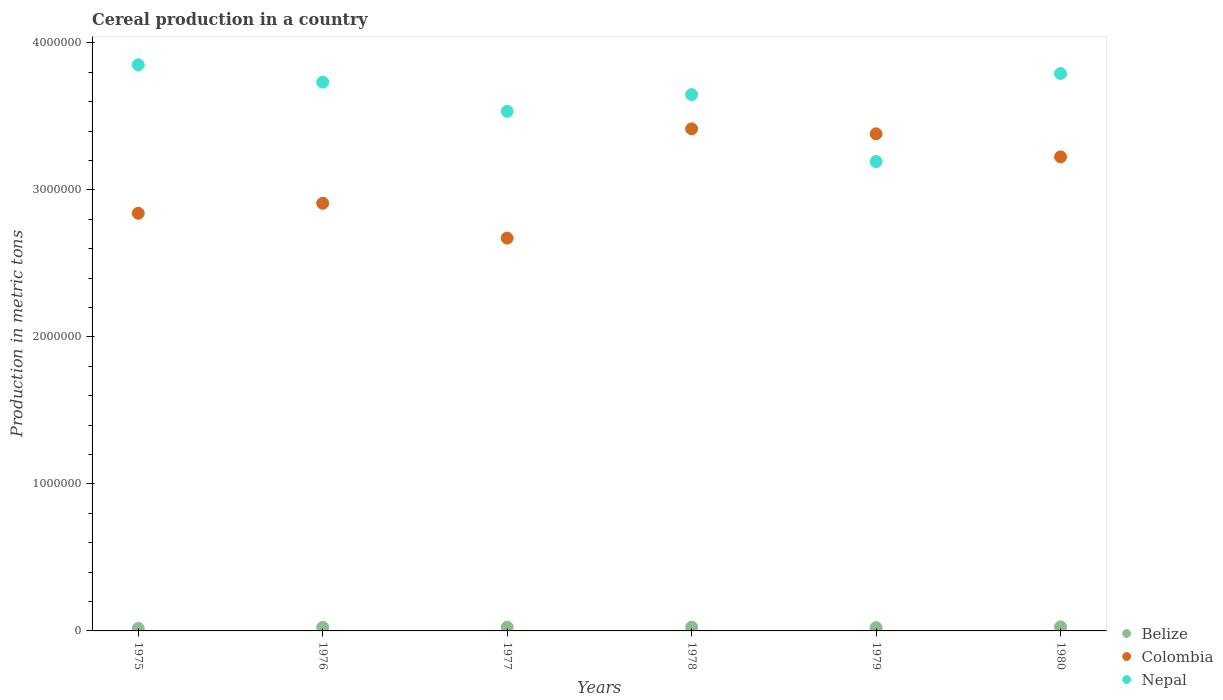Is the number of dotlines equal to the number of legend labels?
Keep it short and to the point. Yes. What is the total cereal production in Colombia in 1975?
Your response must be concise. 2.84e+06. Across all years, what is the maximum total cereal production in Belize?
Give a very brief answer. 2.74e+04. Across all years, what is the minimum total cereal production in Belize?
Offer a very short reply. 1.66e+04. In which year was the total cereal production in Nepal maximum?
Your response must be concise. 1975. In which year was the total cereal production in Colombia minimum?
Provide a succinct answer. 1977. What is the total total cereal production in Belize in the graph?
Your answer should be compact. 1.42e+05. What is the difference between the total cereal production in Colombia in 1976 and that in 1978?
Provide a succinct answer. -5.06e+05. What is the difference between the total cereal production in Nepal in 1978 and the total cereal production in Colombia in 1976?
Give a very brief answer. 7.39e+05. What is the average total cereal production in Nepal per year?
Provide a short and direct response. 3.63e+06. In the year 1980, what is the difference between the total cereal production in Belize and total cereal production in Nepal?
Provide a short and direct response. -3.76e+06. In how many years, is the total cereal production in Nepal greater than 3400000 metric tons?
Offer a terse response. 5. What is the ratio of the total cereal production in Belize in 1977 to that in 1978?
Keep it short and to the point. 0.99. Is the difference between the total cereal production in Belize in 1977 and 1979 greater than the difference between the total cereal production in Nepal in 1977 and 1979?
Offer a terse response. No. What is the difference between the highest and the second highest total cereal production in Nepal?
Your answer should be very brief. 5.95e+04. What is the difference between the highest and the lowest total cereal production in Nepal?
Provide a succinct answer. 6.58e+05. In how many years, is the total cereal production in Belize greater than the average total cereal production in Belize taken over all years?
Offer a terse response. 4. Is the sum of the total cereal production in Belize in 1977 and 1980 greater than the maximum total cereal production in Colombia across all years?
Keep it short and to the point. No. Does the total cereal production in Colombia monotonically increase over the years?
Provide a short and direct response. No. Is the total cereal production in Colombia strictly less than the total cereal production in Belize over the years?
Offer a very short reply. No. Does the graph contain any zero values?
Your response must be concise. No. How are the legend labels stacked?
Your response must be concise. Vertical. What is the title of the graph?
Your answer should be compact. Cereal production in a country. What is the label or title of the Y-axis?
Ensure brevity in your answer.  Production in metric tons. What is the Production in metric tons of Belize in 1975?
Give a very brief answer. 1.66e+04. What is the Production in metric tons of Colombia in 1975?
Offer a very short reply. 2.84e+06. What is the Production in metric tons in Nepal in 1975?
Give a very brief answer. 3.85e+06. What is the Production in metric tons in Belize in 1976?
Your answer should be compact. 2.44e+04. What is the Production in metric tons in Colombia in 1976?
Give a very brief answer. 2.91e+06. What is the Production in metric tons of Nepal in 1976?
Make the answer very short. 3.73e+06. What is the Production in metric tons of Belize in 1977?
Ensure brevity in your answer.  2.56e+04. What is the Production in metric tons of Colombia in 1977?
Provide a short and direct response. 2.67e+06. What is the Production in metric tons in Nepal in 1977?
Make the answer very short. 3.53e+06. What is the Production in metric tons in Belize in 1978?
Your answer should be very brief. 2.59e+04. What is the Production in metric tons in Colombia in 1978?
Provide a succinct answer. 3.42e+06. What is the Production in metric tons of Nepal in 1978?
Your answer should be very brief. 3.65e+06. What is the Production in metric tons in Belize in 1979?
Ensure brevity in your answer.  2.21e+04. What is the Production in metric tons of Colombia in 1979?
Give a very brief answer. 3.38e+06. What is the Production in metric tons in Nepal in 1979?
Give a very brief answer. 3.19e+06. What is the Production in metric tons in Belize in 1980?
Provide a succinct answer. 2.74e+04. What is the Production in metric tons of Colombia in 1980?
Provide a short and direct response. 3.22e+06. What is the Production in metric tons of Nepal in 1980?
Your answer should be compact. 3.79e+06. Across all years, what is the maximum Production in metric tons of Belize?
Your answer should be very brief. 2.74e+04. Across all years, what is the maximum Production in metric tons in Colombia?
Your answer should be very brief. 3.42e+06. Across all years, what is the maximum Production in metric tons in Nepal?
Keep it short and to the point. 3.85e+06. Across all years, what is the minimum Production in metric tons in Belize?
Offer a very short reply. 1.66e+04. Across all years, what is the minimum Production in metric tons of Colombia?
Provide a succinct answer. 2.67e+06. Across all years, what is the minimum Production in metric tons in Nepal?
Provide a short and direct response. 3.19e+06. What is the total Production in metric tons of Belize in the graph?
Provide a short and direct response. 1.42e+05. What is the total Production in metric tons of Colombia in the graph?
Make the answer very short. 1.84e+07. What is the total Production in metric tons in Nepal in the graph?
Offer a very short reply. 2.18e+07. What is the difference between the Production in metric tons of Belize in 1975 and that in 1976?
Your answer should be very brief. -7803. What is the difference between the Production in metric tons in Colombia in 1975 and that in 1976?
Provide a short and direct response. -6.81e+04. What is the difference between the Production in metric tons in Nepal in 1975 and that in 1976?
Your answer should be compact. 1.18e+05. What is the difference between the Production in metric tons in Belize in 1975 and that in 1977?
Offer a very short reply. -8998. What is the difference between the Production in metric tons in Colombia in 1975 and that in 1977?
Offer a terse response. 1.69e+05. What is the difference between the Production in metric tons in Nepal in 1975 and that in 1977?
Your answer should be compact. 3.17e+05. What is the difference between the Production in metric tons in Belize in 1975 and that in 1978?
Ensure brevity in your answer.  -9208. What is the difference between the Production in metric tons in Colombia in 1975 and that in 1978?
Offer a very short reply. -5.74e+05. What is the difference between the Production in metric tons in Nepal in 1975 and that in 1978?
Give a very brief answer. 2.03e+05. What is the difference between the Production in metric tons in Belize in 1975 and that in 1979?
Ensure brevity in your answer.  -5444. What is the difference between the Production in metric tons of Colombia in 1975 and that in 1979?
Keep it short and to the point. -5.41e+05. What is the difference between the Production in metric tons of Nepal in 1975 and that in 1979?
Your answer should be compact. 6.58e+05. What is the difference between the Production in metric tons of Belize in 1975 and that in 1980?
Offer a terse response. -1.08e+04. What is the difference between the Production in metric tons of Colombia in 1975 and that in 1980?
Make the answer very short. -3.84e+05. What is the difference between the Production in metric tons of Nepal in 1975 and that in 1980?
Keep it short and to the point. 5.95e+04. What is the difference between the Production in metric tons in Belize in 1976 and that in 1977?
Keep it short and to the point. -1195. What is the difference between the Production in metric tons in Colombia in 1976 and that in 1977?
Offer a terse response. 2.37e+05. What is the difference between the Production in metric tons in Nepal in 1976 and that in 1977?
Your response must be concise. 1.98e+05. What is the difference between the Production in metric tons of Belize in 1976 and that in 1978?
Your response must be concise. -1405. What is the difference between the Production in metric tons in Colombia in 1976 and that in 1978?
Offer a very short reply. -5.06e+05. What is the difference between the Production in metric tons in Nepal in 1976 and that in 1978?
Provide a succinct answer. 8.46e+04. What is the difference between the Production in metric tons of Belize in 1976 and that in 1979?
Offer a terse response. 2359. What is the difference between the Production in metric tons of Colombia in 1976 and that in 1979?
Provide a short and direct response. -4.72e+05. What is the difference between the Production in metric tons in Nepal in 1976 and that in 1979?
Make the answer very short. 5.40e+05. What is the difference between the Production in metric tons in Belize in 1976 and that in 1980?
Give a very brief answer. -2994. What is the difference between the Production in metric tons of Colombia in 1976 and that in 1980?
Make the answer very short. -3.16e+05. What is the difference between the Production in metric tons of Nepal in 1976 and that in 1980?
Your response must be concise. -5.87e+04. What is the difference between the Production in metric tons of Belize in 1977 and that in 1978?
Make the answer very short. -210. What is the difference between the Production in metric tons of Colombia in 1977 and that in 1978?
Your answer should be compact. -7.44e+05. What is the difference between the Production in metric tons in Nepal in 1977 and that in 1978?
Provide a short and direct response. -1.14e+05. What is the difference between the Production in metric tons in Belize in 1977 and that in 1979?
Make the answer very short. 3554. What is the difference between the Production in metric tons in Colombia in 1977 and that in 1979?
Keep it short and to the point. -7.10e+05. What is the difference between the Production in metric tons in Nepal in 1977 and that in 1979?
Your response must be concise. 3.42e+05. What is the difference between the Production in metric tons of Belize in 1977 and that in 1980?
Your answer should be very brief. -1799. What is the difference between the Production in metric tons of Colombia in 1977 and that in 1980?
Provide a succinct answer. -5.53e+05. What is the difference between the Production in metric tons in Nepal in 1977 and that in 1980?
Offer a terse response. -2.57e+05. What is the difference between the Production in metric tons of Belize in 1978 and that in 1979?
Provide a succinct answer. 3764. What is the difference between the Production in metric tons of Colombia in 1978 and that in 1979?
Ensure brevity in your answer.  3.39e+04. What is the difference between the Production in metric tons of Nepal in 1978 and that in 1979?
Your response must be concise. 4.56e+05. What is the difference between the Production in metric tons in Belize in 1978 and that in 1980?
Ensure brevity in your answer.  -1589. What is the difference between the Production in metric tons in Colombia in 1978 and that in 1980?
Keep it short and to the point. 1.91e+05. What is the difference between the Production in metric tons of Nepal in 1978 and that in 1980?
Your answer should be very brief. -1.43e+05. What is the difference between the Production in metric tons in Belize in 1979 and that in 1980?
Provide a succinct answer. -5353. What is the difference between the Production in metric tons in Colombia in 1979 and that in 1980?
Make the answer very short. 1.57e+05. What is the difference between the Production in metric tons in Nepal in 1979 and that in 1980?
Offer a terse response. -5.99e+05. What is the difference between the Production in metric tons of Belize in 1975 and the Production in metric tons of Colombia in 1976?
Provide a succinct answer. -2.89e+06. What is the difference between the Production in metric tons in Belize in 1975 and the Production in metric tons in Nepal in 1976?
Give a very brief answer. -3.72e+06. What is the difference between the Production in metric tons in Colombia in 1975 and the Production in metric tons in Nepal in 1976?
Offer a terse response. -8.92e+05. What is the difference between the Production in metric tons of Belize in 1975 and the Production in metric tons of Colombia in 1977?
Your response must be concise. -2.66e+06. What is the difference between the Production in metric tons of Belize in 1975 and the Production in metric tons of Nepal in 1977?
Ensure brevity in your answer.  -3.52e+06. What is the difference between the Production in metric tons in Colombia in 1975 and the Production in metric tons in Nepal in 1977?
Give a very brief answer. -6.94e+05. What is the difference between the Production in metric tons in Belize in 1975 and the Production in metric tons in Colombia in 1978?
Make the answer very short. -3.40e+06. What is the difference between the Production in metric tons of Belize in 1975 and the Production in metric tons of Nepal in 1978?
Make the answer very short. -3.63e+06. What is the difference between the Production in metric tons of Colombia in 1975 and the Production in metric tons of Nepal in 1978?
Keep it short and to the point. -8.07e+05. What is the difference between the Production in metric tons of Belize in 1975 and the Production in metric tons of Colombia in 1979?
Keep it short and to the point. -3.37e+06. What is the difference between the Production in metric tons of Belize in 1975 and the Production in metric tons of Nepal in 1979?
Your answer should be compact. -3.18e+06. What is the difference between the Production in metric tons in Colombia in 1975 and the Production in metric tons in Nepal in 1979?
Ensure brevity in your answer.  -3.52e+05. What is the difference between the Production in metric tons of Belize in 1975 and the Production in metric tons of Colombia in 1980?
Give a very brief answer. -3.21e+06. What is the difference between the Production in metric tons of Belize in 1975 and the Production in metric tons of Nepal in 1980?
Your response must be concise. -3.78e+06. What is the difference between the Production in metric tons of Colombia in 1975 and the Production in metric tons of Nepal in 1980?
Offer a terse response. -9.51e+05. What is the difference between the Production in metric tons of Belize in 1976 and the Production in metric tons of Colombia in 1977?
Your answer should be compact. -2.65e+06. What is the difference between the Production in metric tons of Belize in 1976 and the Production in metric tons of Nepal in 1977?
Provide a short and direct response. -3.51e+06. What is the difference between the Production in metric tons in Colombia in 1976 and the Production in metric tons in Nepal in 1977?
Your answer should be compact. -6.25e+05. What is the difference between the Production in metric tons in Belize in 1976 and the Production in metric tons in Colombia in 1978?
Provide a succinct answer. -3.39e+06. What is the difference between the Production in metric tons in Belize in 1976 and the Production in metric tons in Nepal in 1978?
Ensure brevity in your answer.  -3.62e+06. What is the difference between the Production in metric tons of Colombia in 1976 and the Production in metric tons of Nepal in 1978?
Ensure brevity in your answer.  -7.39e+05. What is the difference between the Production in metric tons in Belize in 1976 and the Production in metric tons in Colombia in 1979?
Keep it short and to the point. -3.36e+06. What is the difference between the Production in metric tons of Belize in 1976 and the Production in metric tons of Nepal in 1979?
Provide a short and direct response. -3.17e+06. What is the difference between the Production in metric tons of Colombia in 1976 and the Production in metric tons of Nepal in 1979?
Offer a very short reply. -2.84e+05. What is the difference between the Production in metric tons in Belize in 1976 and the Production in metric tons in Colombia in 1980?
Provide a succinct answer. -3.20e+06. What is the difference between the Production in metric tons in Belize in 1976 and the Production in metric tons in Nepal in 1980?
Offer a very short reply. -3.77e+06. What is the difference between the Production in metric tons in Colombia in 1976 and the Production in metric tons in Nepal in 1980?
Your answer should be very brief. -8.83e+05. What is the difference between the Production in metric tons in Belize in 1977 and the Production in metric tons in Colombia in 1978?
Make the answer very short. -3.39e+06. What is the difference between the Production in metric tons in Belize in 1977 and the Production in metric tons in Nepal in 1978?
Offer a terse response. -3.62e+06. What is the difference between the Production in metric tons in Colombia in 1977 and the Production in metric tons in Nepal in 1978?
Keep it short and to the point. -9.77e+05. What is the difference between the Production in metric tons in Belize in 1977 and the Production in metric tons in Colombia in 1979?
Your response must be concise. -3.36e+06. What is the difference between the Production in metric tons of Belize in 1977 and the Production in metric tons of Nepal in 1979?
Provide a succinct answer. -3.17e+06. What is the difference between the Production in metric tons in Colombia in 1977 and the Production in metric tons in Nepal in 1979?
Keep it short and to the point. -5.21e+05. What is the difference between the Production in metric tons of Belize in 1977 and the Production in metric tons of Colombia in 1980?
Your answer should be very brief. -3.20e+06. What is the difference between the Production in metric tons in Belize in 1977 and the Production in metric tons in Nepal in 1980?
Your answer should be compact. -3.77e+06. What is the difference between the Production in metric tons in Colombia in 1977 and the Production in metric tons in Nepal in 1980?
Give a very brief answer. -1.12e+06. What is the difference between the Production in metric tons of Belize in 1978 and the Production in metric tons of Colombia in 1979?
Offer a very short reply. -3.36e+06. What is the difference between the Production in metric tons of Belize in 1978 and the Production in metric tons of Nepal in 1979?
Ensure brevity in your answer.  -3.17e+06. What is the difference between the Production in metric tons of Colombia in 1978 and the Production in metric tons of Nepal in 1979?
Your answer should be very brief. 2.23e+05. What is the difference between the Production in metric tons of Belize in 1978 and the Production in metric tons of Colombia in 1980?
Provide a short and direct response. -3.20e+06. What is the difference between the Production in metric tons in Belize in 1978 and the Production in metric tons in Nepal in 1980?
Keep it short and to the point. -3.77e+06. What is the difference between the Production in metric tons in Colombia in 1978 and the Production in metric tons in Nepal in 1980?
Give a very brief answer. -3.76e+05. What is the difference between the Production in metric tons of Belize in 1979 and the Production in metric tons of Colombia in 1980?
Offer a very short reply. -3.20e+06. What is the difference between the Production in metric tons in Belize in 1979 and the Production in metric tons in Nepal in 1980?
Keep it short and to the point. -3.77e+06. What is the difference between the Production in metric tons of Colombia in 1979 and the Production in metric tons of Nepal in 1980?
Your response must be concise. -4.10e+05. What is the average Production in metric tons in Belize per year?
Make the answer very short. 2.37e+04. What is the average Production in metric tons in Colombia per year?
Provide a short and direct response. 3.07e+06. What is the average Production in metric tons in Nepal per year?
Ensure brevity in your answer.  3.63e+06. In the year 1975, what is the difference between the Production in metric tons in Belize and Production in metric tons in Colombia?
Ensure brevity in your answer.  -2.82e+06. In the year 1975, what is the difference between the Production in metric tons of Belize and Production in metric tons of Nepal?
Your answer should be very brief. -3.83e+06. In the year 1975, what is the difference between the Production in metric tons of Colombia and Production in metric tons of Nepal?
Offer a terse response. -1.01e+06. In the year 1976, what is the difference between the Production in metric tons of Belize and Production in metric tons of Colombia?
Your response must be concise. -2.88e+06. In the year 1976, what is the difference between the Production in metric tons of Belize and Production in metric tons of Nepal?
Ensure brevity in your answer.  -3.71e+06. In the year 1976, what is the difference between the Production in metric tons of Colombia and Production in metric tons of Nepal?
Give a very brief answer. -8.24e+05. In the year 1977, what is the difference between the Production in metric tons of Belize and Production in metric tons of Colombia?
Offer a terse response. -2.65e+06. In the year 1977, what is the difference between the Production in metric tons of Belize and Production in metric tons of Nepal?
Offer a terse response. -3.51e+06. In the year 1977, what is the difference between the Production in metric tons of Colombia and Production in metric tons of Nepal?
Offer a terse response. -8.63e+05. In the year 1978, what is the difference between the Production in metric tons of Belize and Production in metric tons of Colombia?
Offer a very short reply. -3.39e+06. In the year 1978, what is the difference between the Production in metric tons in Belize and Production in metric tons in Nepal?
Offer a terse response. -3.62e+06. In the year 1978, what is the difference between the Production in metric tons of Colombia and Production in metric tons of Nepal?
Provide a short and direct response. -2.33e+05. In the year 1979, what is the difference between the Production in metric tons in Belize and Production in metric tons in Colombia?
Offer a terse response. -3.36e+06. In the year 1979, what is the difference between the Production in metric tons of Belize and Production in metric tons of Nepal?
Provide a succinct answer. -3.17e+06. In the year 1979, what is the difference between the Production in metric tons of Colombia and Production in metric tons of Nepal?
Make the answer very short. 1.89e+05. In the year 1980, what is the difference between the Production in metric tons in Belize and Production in metric tons in Colombia?
Keep it short and to the point. -3.20e+06. In the year 1980, what is the difference between the Production in metric tons in Belize and Production in metric tons in Nepal?
Give a very brief answer. -3.76e+06. In the year 1980, what is the difference between the Production in metric tons of Colombia and Production in metric tons of Nepal?
Your answer should be compact. -5.67e+05. What is the ratio of the Production in metric tons of Belize in 1975 to that in 1976?
Your answer should be very brief. 0.68. What is the ratio of the Production in metric tons in Colombia in 1975 to that in 1976?
Provide a short and direct response. 0.98. What is the ratio of the Production in metric tons in Nepal in 1975 to that in 1976?
Offer a very short reply. 1.03. What is the ratio of the Production in metric tons in Belize in 1975 to that in 1977?
Provide a succinct answer. 0.65. What is the ratio of the Production in metric tons of Colombia in 1975 to that in 1977?
Your response must be concise. 1.06. What is the ratio of the Production in metric tons in Nepal in 1975 to that in 1977?
Your answer should be compact. 1.09. What is the ratio of the Production in metric tons of Belize in 1975 to that in 1978?
Offer a terse response. 0.64. What is the ratio of the Production in metric tons of Colombia in 1975 to that in 1978?
Your answer should be very brief. 0.83. What is the ratio of the Production in metric tons in Nepal in 1975 to that in 1978?
Your response must be concise. 1.06. What is the ratio of the Production in metric tons in Belize in 1975 to that in 1979?
Ensure brevity in your answer.  0.75. What is the ratio of the Production in metric tons of Colombia in 1975 to that in 1979?
Offer a very short reply. 0.84. What is the ratio of the Production in metric tons in Nepal in 1975 to that in 1979?
Provide a short and direct response. 1.21. What is the ratio of the Production in metric tons of Belize in 1975 to that in 1980?
Make the answer very short. 0.61. What is the ratio of the Production in metric tons of Colombia in 1975 to that in 1980?
Offer a terse response. 0.88. What is the ratio of the Production in metric tons of Nepal in 1975 to that in 1980?
Your answer should be compact. 1.02. What is the ratio of the Production in metric tons of Belize in 1976 to that in 1977?
Your response must be concise. 0.95. What is the ratio of the Production in metric tons of Colombia in 1976 to that in 1977?
Your answer should be very brief. 1.09. What is the ratio of the Production in metric tons of Nepal in 1976 to that in 1977?
Give a very brief answer. 1.06. What is the ratio of the Production in metric tons of Belize in 1976 to that in 1978?
Provide a succinct answer. 0.95. What is the ratio of the Production in metric tons of Colombia in 1976 to that in 1978?
Offer a very short reply. 0.85. What is the ratio of the Production in metric tons in Nepal in 1976 to that in 1978?
Ensure brevity in your answer.  1.02. What is the ratio of the Production in metric tons in Belize in 1976 to that in 1979?
Keep it short and to the point. 1.11. What is the ratio of the Production in metric tons of Colombia in 1976 to that in 1979?
Provide a succinct answer. 0.86. What is the ratio of the Production in metric tons in Nepal in 1976 to that in 1979?
Your response must be concise. 1.17. What is the ratio of the Production in metric tons in Belize in 1976 to that in 1980?
Give a very brief answer. 0.89. What is the ratio of the Production in metric tons in Colombia in 1976 to that in 1980?
Keep it short and to the point. 0.9. What is the ratio of the Production in metric tons of Nepal in 1976 to that in 1980?
Keep it short and to the point. 0.98. What is the ratio of the Production in metric tons of Belize in 1977 to that in 1978?
Your answer should be very brief. 0.99. What is the ratio of the Production in metric tons in Colombia in 1977 to that in 1978?
Your answer should be compact. 0.78. What is the ratio of the Production in metric tons of Nepal in 1977 to that in 1978?
Your answer should be compact. 0.97. What is the ratio of the Production in metric tons in Belize in 1977 to that in 1979?
Ensure brevity in your answer.  1.16. What is the ratio of the Production in metric tons of Colombia in 1977 to that in 1979?
Your answer should be very brief. 0.79. What is the ratio of the Production in metric tons of Nepal in 1977 to that in 1979?
Provide a short and direct response. 1.11. What is the ratio of the Production in metric tons in Belize in 1977 to that in 1980?
Give a very brief answer. 0.93. What is the ratio of the Production in metric tons of Colombia in 1977 to that in 1980?
Make the answer very short. 0.83. What is the ratio of the Production in metric tons in Nepal in 1977 to that in 1980?
Keep it short and to the point. 0.93. What is the ratio of the Production in metric tons in Belize in 1978 to that in 1979?
Your response must be concise. 1.17. What is the ratio of the Production in metric tons of Colombia in 1978 to that in 1979?
Your answer should be compact. 1.01. What is the ratio of the Production in metric tons in Nepal in 1978 to that in 1979?
Your answer should be very brief. 1.14. What is the ratio of the Production in metric tons of Belize in 1978 to that in 1980?
Your answer should be very brief. 0.94. What is the ratio of the Production in metric tons of Colombia in 1978 to that in 1980?
Provide a short and direct response. 1.06. What is the ratio of the Production in metric tons in Nepal in 1978 to that in 1980?
Your answer should be compact. 0.96. What is the ratio of the Production in metric tons in Belize in 1979 to that in 1980?
Your answer should be compact. 0.8. What is the ratio of the Production in metric tons of Colombia in 1979 to that in 1980?
Offer a very short reply. 1.05. What is the ratio of the Production in metric tons of Nepal in 1979 to that in 1980?
Provide a short and direct response. 0.84. What is the difference between the highest and the second highest Production in metric tons of Belize?
Provide a short and direct response. 1589. What is the difference between the highest and the second highest Production in metric tons in Colombia?
Offer a very short reply. 3.39e+04. What is the difference between the highest and the second highest Production in metric tons in Nepal?
Offer a very short reply. 5.95e+04. What is the difference between the highest and the lowest Production in metric tons of Belize?
Your answer should be compact. 1.08e+04. What is the difference between the highest and the lowest Production in metric tons of Colombia?
Your answer should be compact. 7.44e+05. What is the difference between the highest and the lowest Production in metric tons in Nepal?
Your response must be concise. 6.58e+05. 